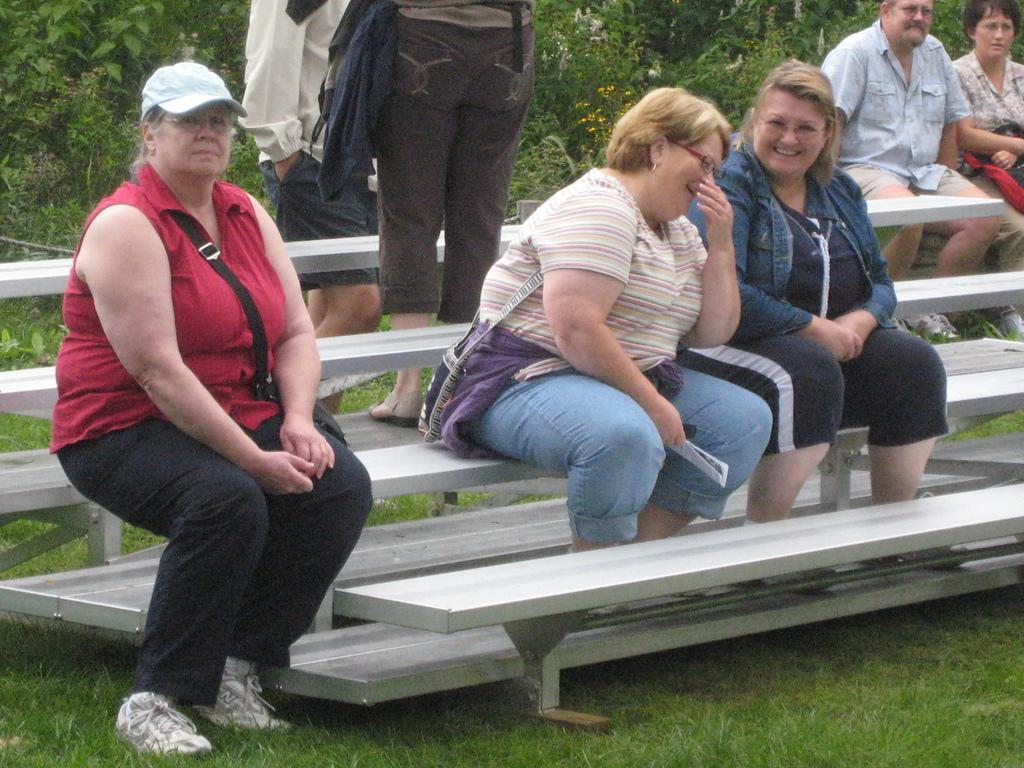How would you summarize this image in a sentence or two? In the center we can see three women were sitting on the bench and they were smiling. In the background there is a tree,plant,grass and few persons were sitting and standing. 